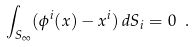<formula> <loc_0><loc_0><loc_500><loc_500>\int _ { S _ { \infty } } ( \phi ^ { i } ( x ) - x ^ { i } ) \, d S _ { i } = 0 \ .</formula> 